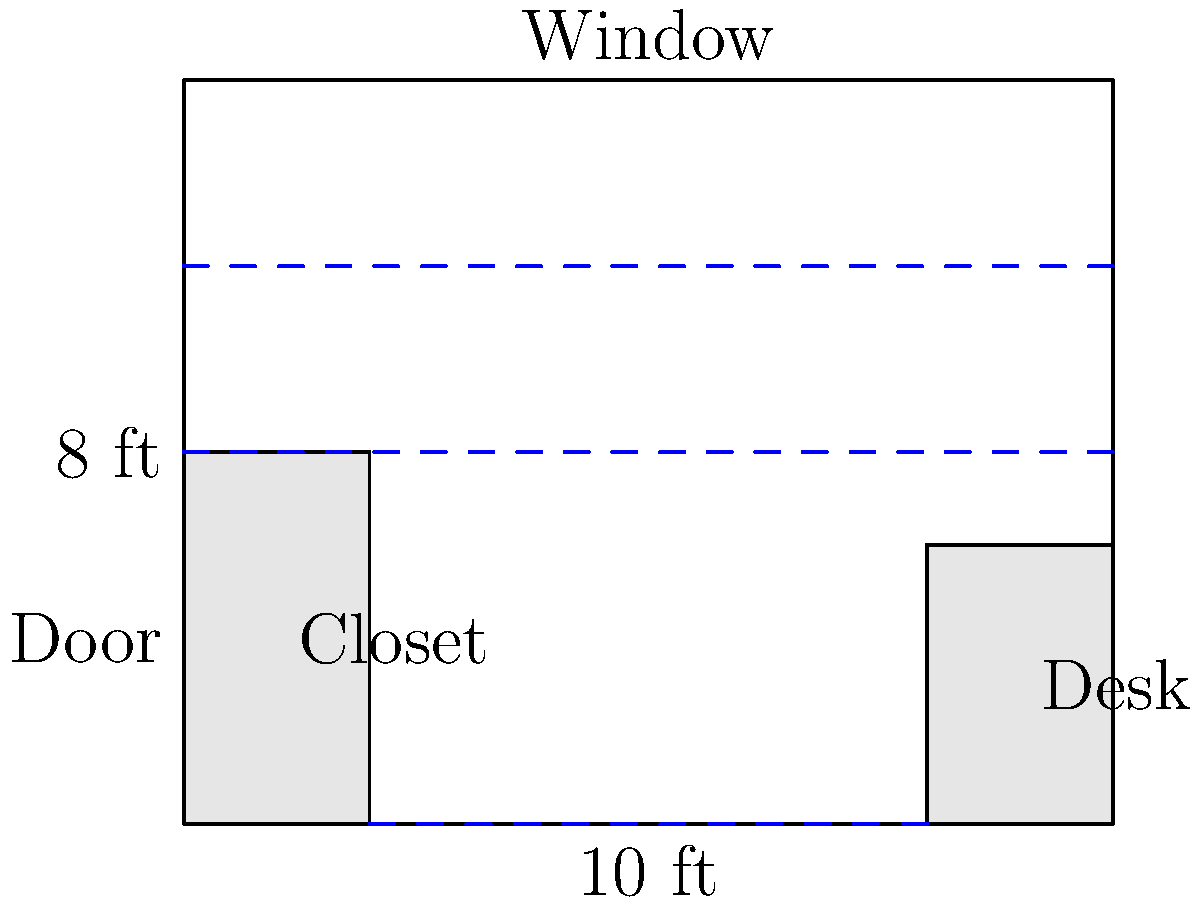As an author preparing to organize your latest manuscripts and research materials, you need to maximize bookshelf space in your study. Given the room layout shown, with existing furniture and wall space limitations, what is the maximum total length of bookshelves (in feet) that can be installed along the available wall space? Assume bookshelves are 1 foot deep and can be placed along any free wall space. Let's approach this step-by-step:

1. Identify available wall space:
   - Bottom wall: 6 ft (between closet and desk)
   - Left wall: 4 ft (above closet)
   - Right wall: 5 ft (above desk)
   - Top wall: 10 ft (below window)

2. Calculate total available space:
   $6 + 4 + 5 + 10 = 25$ ft

3. Consider depth limitations:
   - The room is 8 ft deep
   - Bookshelves are 1 ft deep
   - We can place shelves along all walls without interference

4. Check for any restrictions:
   - No restrictions mentioned for placing shelves above furniture
   - Door and window do not affect available space as calculated

5. Sum up the total length:
   The maximum total length of bookshelves = $25$ ft

This arrangement allows for optimal use of the available wall space, providing ample storage for manuscripts and research materials while maintaining the existing furniture layout.
Answer: 25 feet 